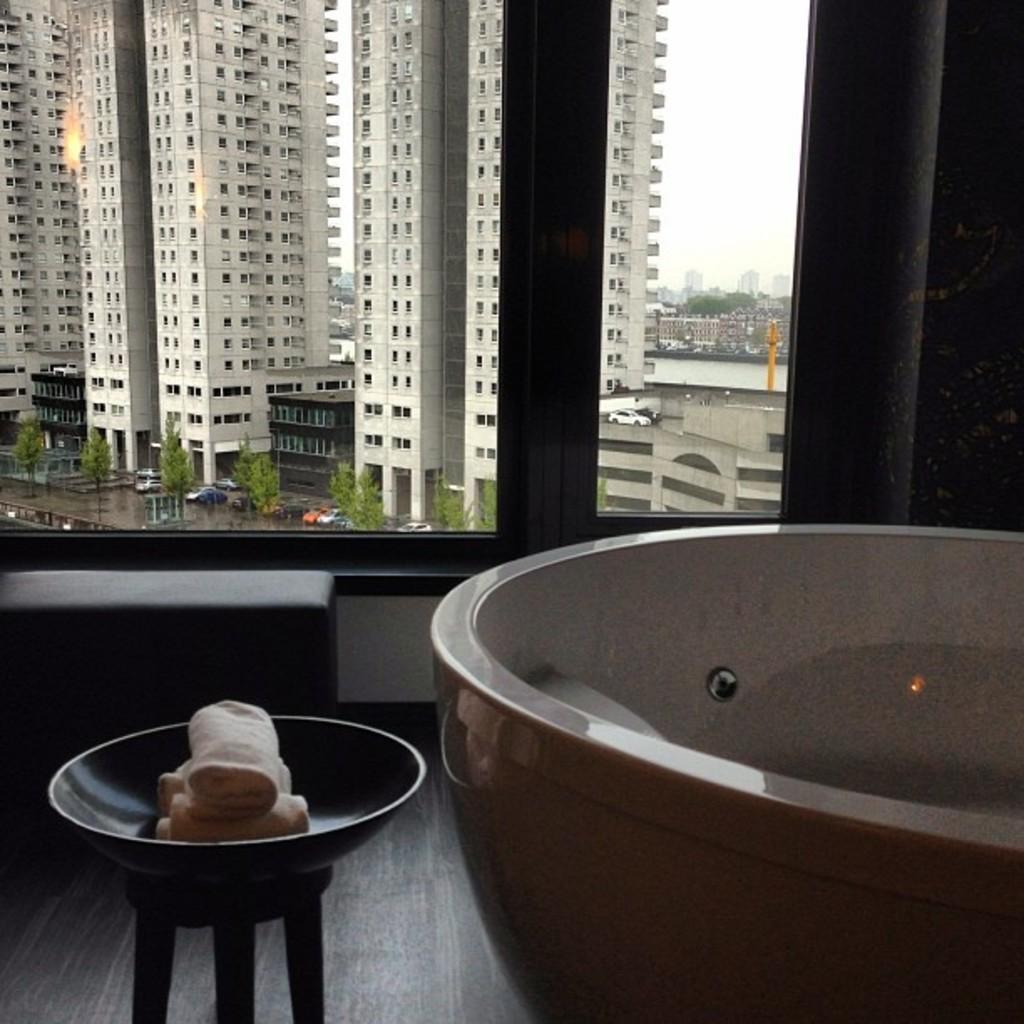Describe this image in one or two sentences. This is inside view of a room. We can see a tub, objects in a bowl on a stool and a platform on the floor. Through the window glasses we can see buildings, trees, vehicles on the road, water, pole and the sky. 